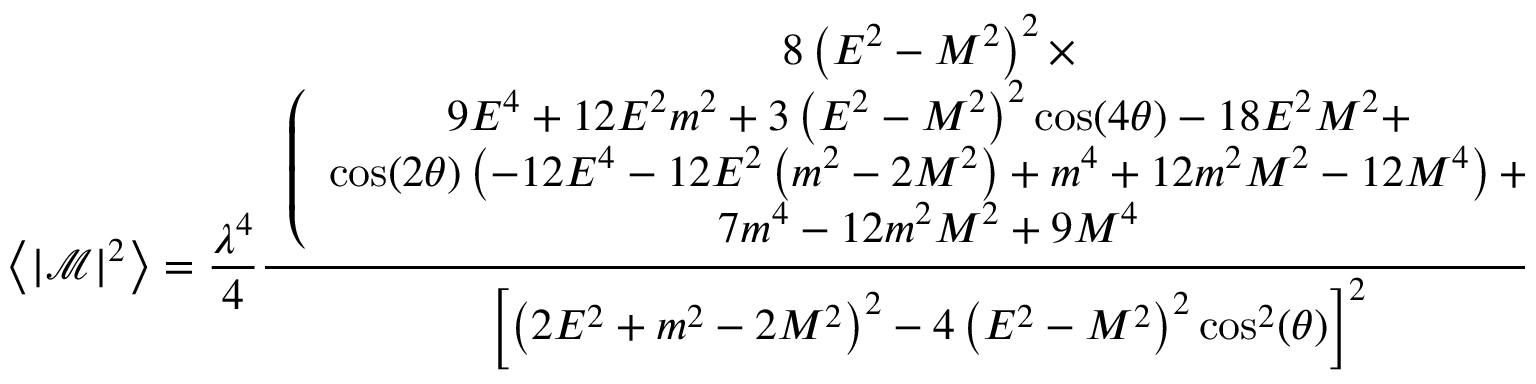<formula> <loc_0><loc_0><loc_500><loc_500>\left \langle \left | \mathcal { M } \right | ^ { 2 } \right \rangle = \frac { \lambda ^ { 4 } } { 4 } \frac { \begin{array} { c } { 8 \left ( E ^ { 2 } - M ^ { 2 } \right ) ^ { 2 } \times } \\ { \left ( \begin{array} { c } { 9 E ^ { 4 } + 1 2 E ^ { 2 } m ^ { 2 } + 3 \left ( E ^ { 2 } - M ^ { 2 } \right ) ^ { 2 } \cos ( 4 \theta ) - 1 8 E ^ { 2 } M ^ { 2 } + } \\ { \cos ( 2 \theta ) \left ( - 1 2 E ^ { 4 } - 1 2 E ^ { 2 } \left ( m ^ { 2 } - 2 M ^ { 2 } \right ) + m ^ { 4 } + 1 2 m ^ { 2 } M ^ { 2 } - 1 2 M ^ { 4 } \right ) + } \\ { 7 m ^ { 4 } - 1 2 m ^ { 2 } M ^ { 2 } + 9 M ^ { 4 } } \end{array} \right ) } \end{array} } { \left [ \left ( 2 E ^ { 2 } + m ^ { 2 } - 2 M ^ { 2 } \right ) ^ { 2 } - 4 \left ( E ^ { 2 } - M ^ { 2 } \right ) ^ { 2 } \cos ^ { 2 } ( \theta ) \right ] ^ { 2 } } .</formula> 